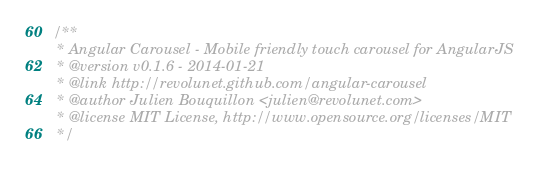Convert code to text. <code><loc_0><loc_0><loc_500><loc_500><_JavaScript_>/**
 * Angular Carousel - Mobile friendly touch carousel for AngularJS
 * @version v0.1.6 - 2014-01-21
 * @link http://revolunet.github.com/angular-carousel
 * @author Julien Bouquillon <julien@revolunet.com>
 * @license MIT License, http://www.opensource.org/licenses/MIT
 */</code> 